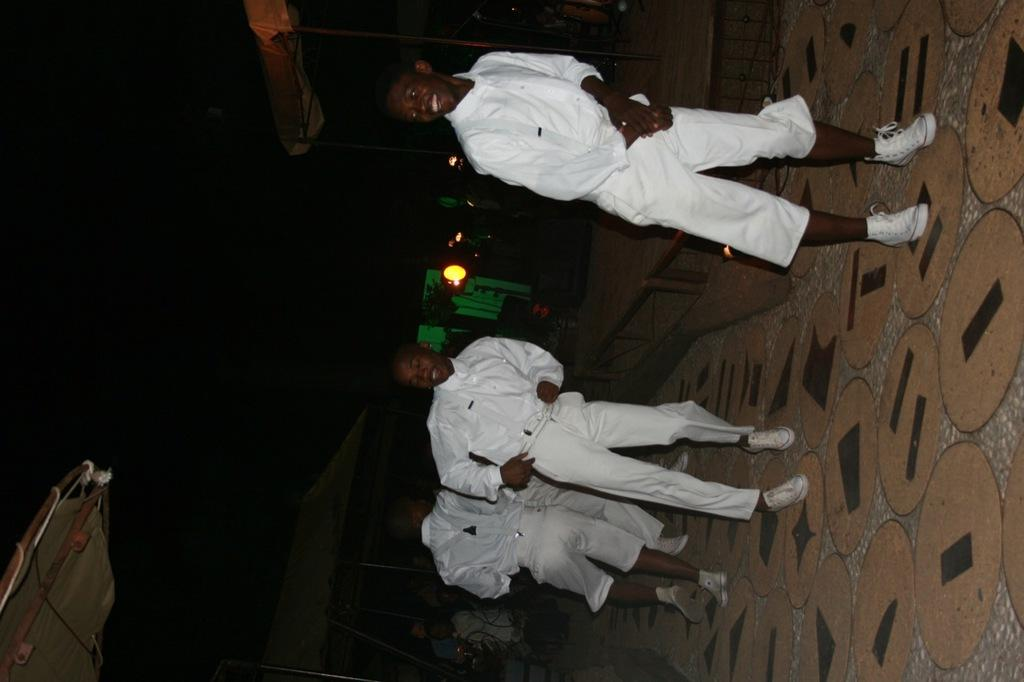Who or what is present in the image? There are people in the image. What are the people wearing? The people are wearing white dresses. Where are the people standing? The people are standing on the floor. What can be seen behind the people? There are objects or elements behind the people. What type of shade is being used by the people in the image? There is no shade present in the image; the people are standing on the floor with no visible covering or protection. 